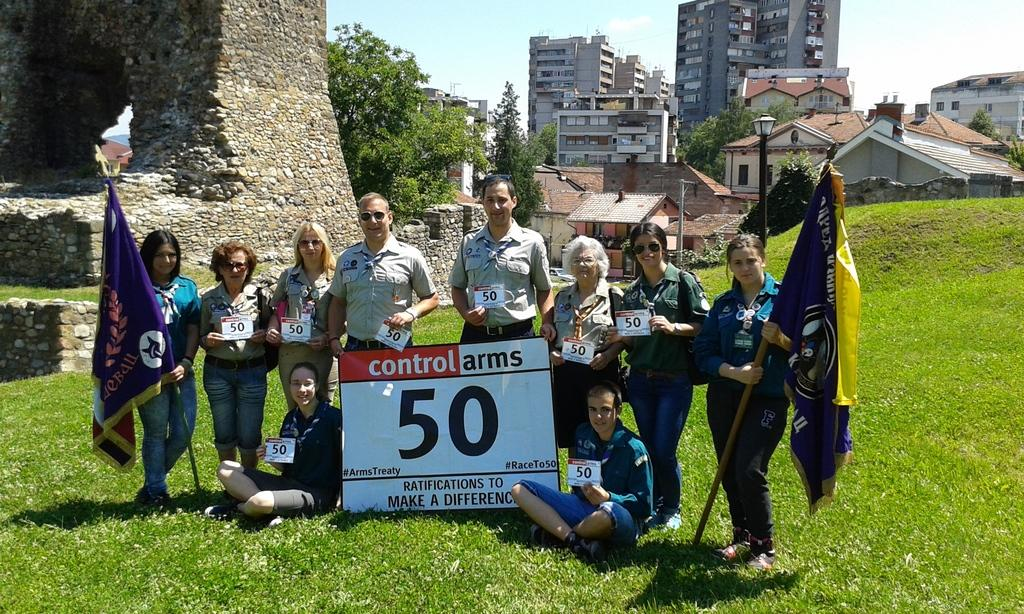What type of surface is visible in the image? There is ground visible in the image. What type of vegetation is present in the image? There is grass in the image. What are the people in the image doing? The people are standing and sitting in the image. What are the people holding in the image? The people are holding flags and banners in the image. What can be seen in the background of the image? There are buildings, trees, and the sky visible in the background of the image. What month is it in the image? There is no specific month mentioned or depicted in the image. Can you tell me how many railway tracks are visible in the image? There are no railway tracks present in the image. 